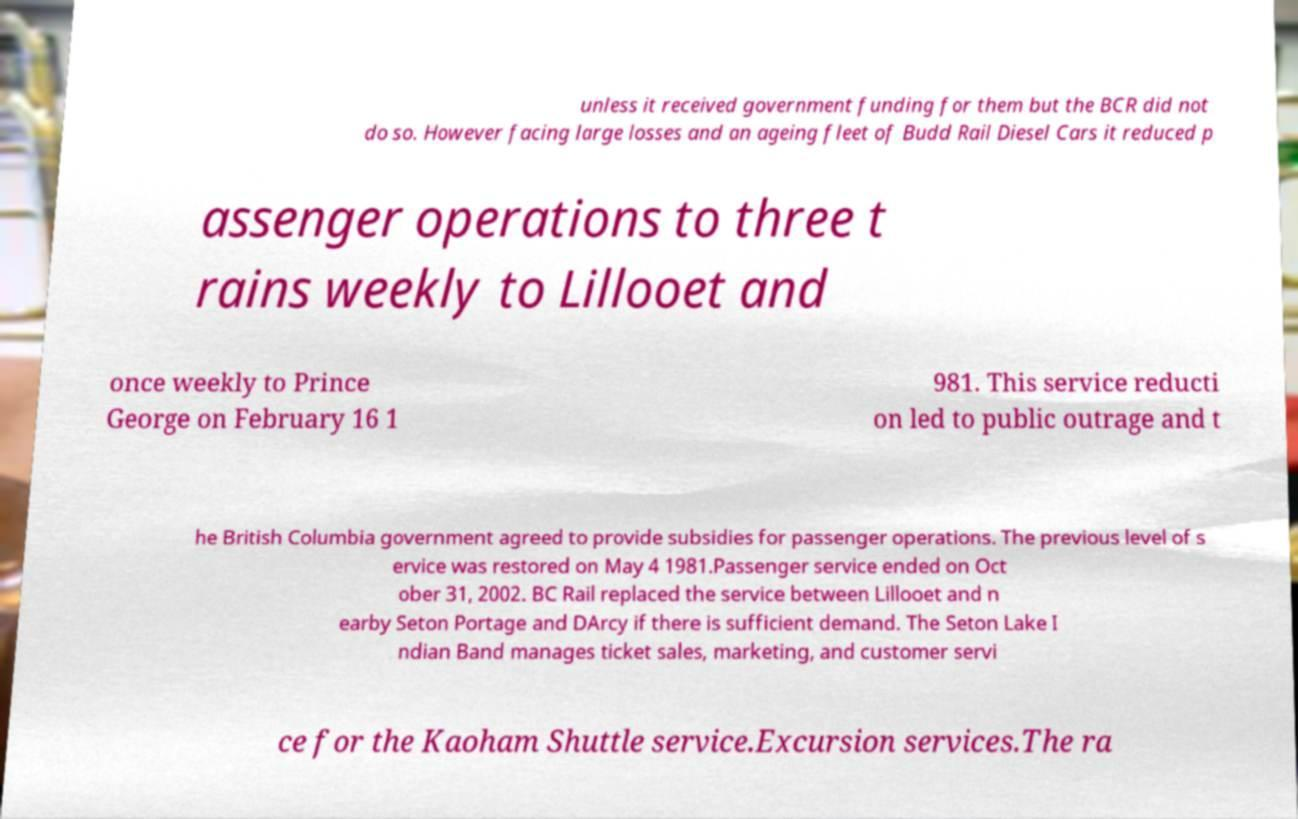Could you extract and type out the text from this image? unless it received government funding for them but the BCR did not do so. However facing large losses and an ageing fleet of Budd Rail Diesel Cars it reduced p assenger operations to three t rains weekly to Lillooet and once weekly to Prince George on February 16 1 981. This service reducti on led to public outrage and t he British Columbia government agreed to provide subsidies for passenger operations. The previous level of s ervice was restored on May 4 1981.Passenger service ended on Oct ober 31, 2002. BC Rail replaced the service between Lillooet and n earby Seton Portage and DArcy if there is sufficient demand. The Seton Lake I ndian Band manages ticket sales, marketing, and customer servi ce for the Kaoham Shuttle service.Excursion services.The ra 